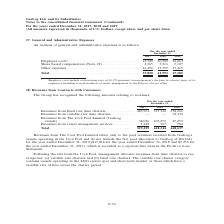From Gaslog's financial document, In which year was the general and administrative expenses recorded for? The document contains multiple relevant values: 2017, 2018, 2019. From the document: "For the year ended December 31, 2017 2018 2019 For the year ended December 31, 2017 2018 2019 For the year ended December 31, 2017 2018 2019..." Also, What was the cost of restructuring? According to the financial document, $3,975 (in thousands). The relevant text states: "* Employee costs include restructuring costs of $3,975 pursuant to management’s decision to relocate more of its employees including several members of sen..." Also, Where does the management intend to relocate its employees? Piraeus, Greece office. The document states: "uding several members of senior management to the Piraeus, Greece office...." Additionally, Which year has the highest share-based compensation? According to the financial document, 2018. The relevant text states: "For the year ended December 31, 2017 2018 2019..." Also, can you calculate: What was the change in other expenses from 2018 to 2019? Based on the calculation: 17,415 - 15,797 , the result is 1618 (in thousands). This is based on the information: "4,565 5,216 5,107 Other expenses . 16,496 15,797 17,415 e 22) . 4,565 5,216 5,107 Other expenses . 16,496 15,797 17,415..." The key data points involved are: 15,797, 17,415. Also, can you calculate: What was the percentage change in employee costs from 2017 to 2018? To answer this question, I need to perform calculations using the financial data. The calculation is: (20,980 - 18,789)/18,789 , which equals 11.66 (percentage). This is based on the information: "Employee costs* . 18,789 20,980 24,863 Share-based compensation (Note 22) . 4,565 5,216 5,107 Other expenses . 16,496 15,797 Employee costs* . 18,789 20,980 24,863 Share-based compensation (Note 22) ...." The key data points involved are: 18,789, 20,980. 